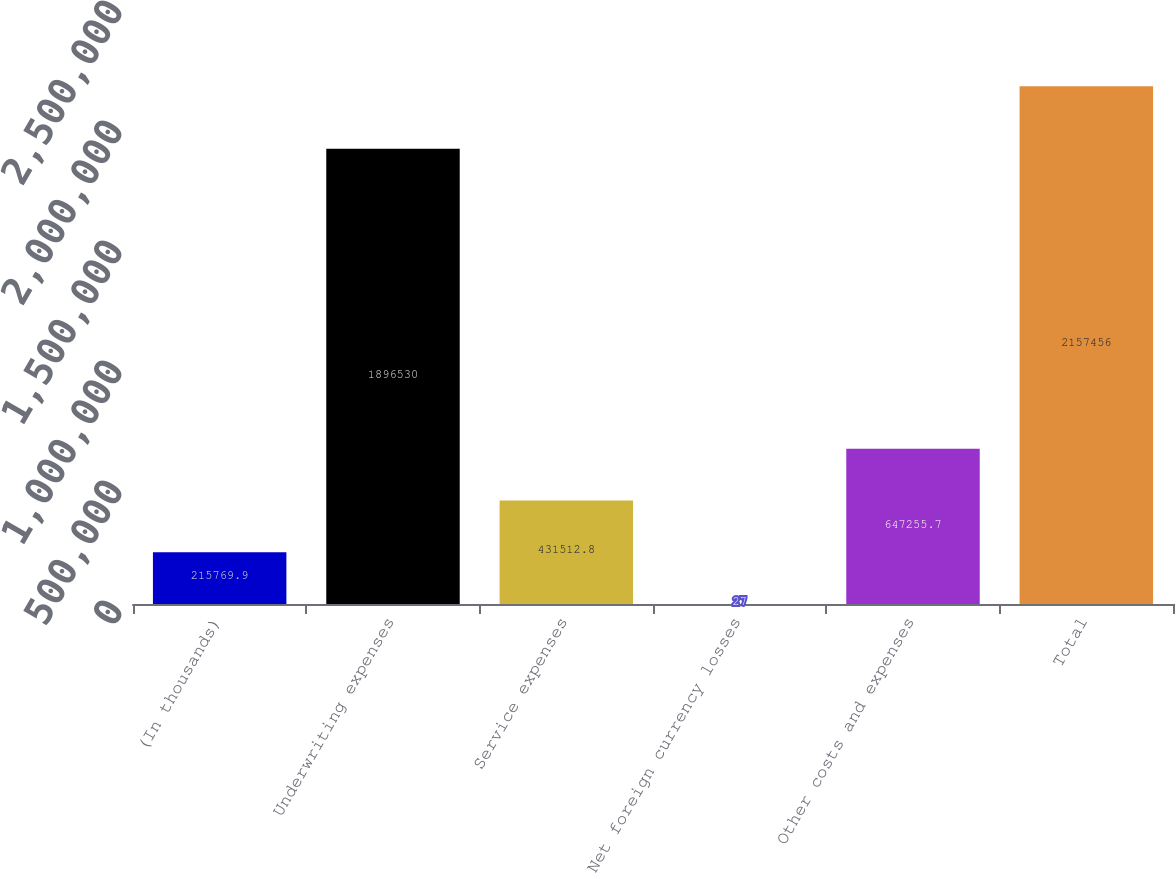<chart> <loc_0><loc_0><loc_500><loc_500><bar_chart><fcel>(In thousands)<fcel>Underwriting expenses<fcel>Service expenses<fcel>Net foreign currency losses<fcel>Other costs and expenses<fcel>Total<nl><fcel>215770<fcel>1.89653e+06<fcel>431513<fcel>27<fcel>647256<fcel>2.15746e+06<nl></chart> 